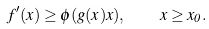Convert formula to latex. <formula><loc_0><loc_0><loc_500><loc_500>f ^ { \prime } ( x ) \geq \phi ( g ( x ) x ) , \quad x \geq x _ { 0 } .</formula> 